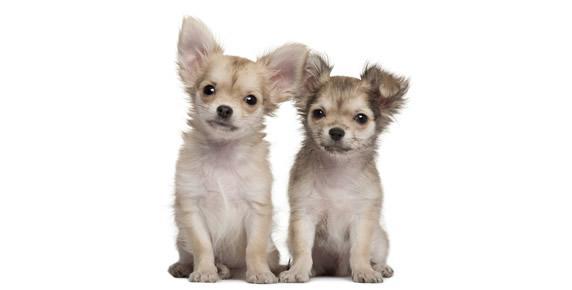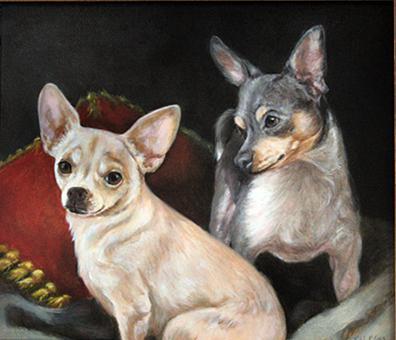The first image is the image on the left, the second image is the image on the right. Considering the images on both sides, is "Two chihuahuas in different poses are posed together indoors wearing some type of garment." valid? Answer yes or no. No. The first image is the image on the left, the second image is the image on the right. For the images displayed, is the sentence "Exactly four dogs are shown, two in each image, with two in one image wearing outer wear, each in a different color, even though they are inside." factually correct? Answer yes or no. No. 